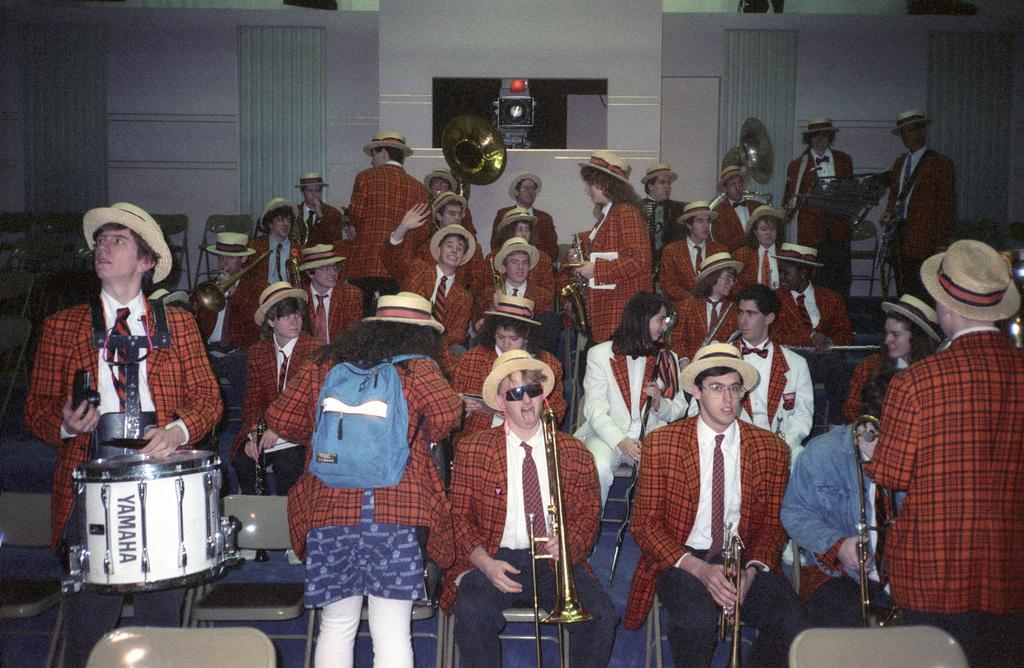How many people are in the image? There is a group of persons in the image. What are the people wearing? The persons are wearing similar dress. What are the people doing in the image? The persons are playing musical instruments. What type of tools does the carpenter use in the image? There is no carpenter present in the image; it features a group of persons playing musical instruments. What type of fruit is being used as a prop in the image? There is no fruit present in the image. 